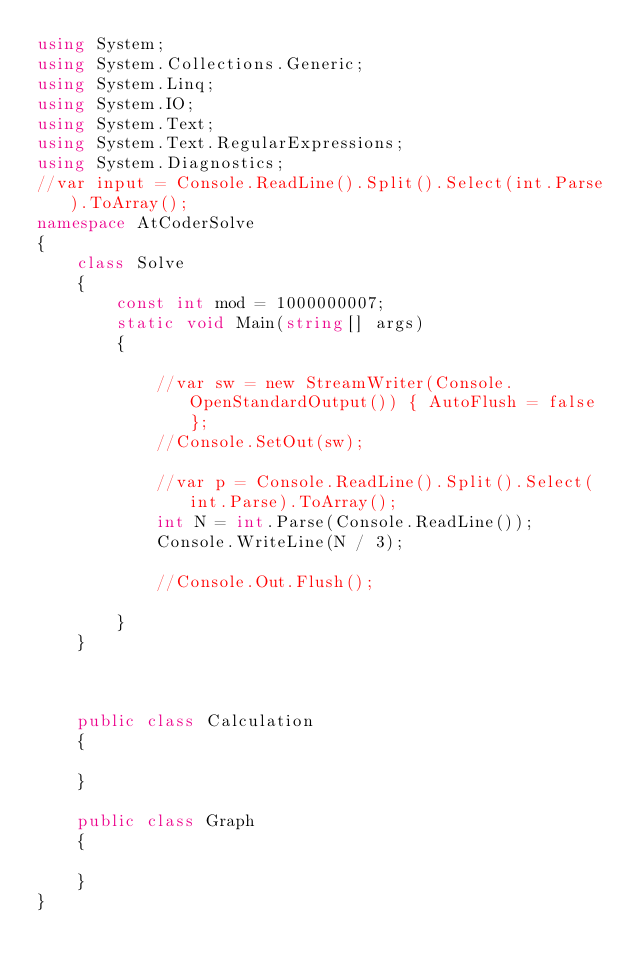<code> <loc_0><loc_0><loc_500><loc_500><_C#_>using System;
using System.Collections.Generic;
using System.Linq;
using System.IO;
using System.Text;
using System.Text.RegularExpressions;
using System.Diagnostics;
//var input = Console.ReadLine().Split().Select(int.Parse).ToArray();
namespace AtCoderSolve
{
    class Solve
    {
        const int mod = 1000000007;
        static void Main(string[] args)
        {

            //var sw = new StreamWriter(Console.OpenStandardOutput()) { AutoFlush = false };
            //Console.SetOut(sw);

            //var p = Console.ReadLine().Split().Select(int.Parse).ToArray();
            int N = int.Parse(Console.ReadLine());
            Console.WriteLine(N / 3);

            //Console.Out.Flush();

        }
    }



    public class Calculation
    {

    }

    public class Graph
    {

    }
}
</code> 